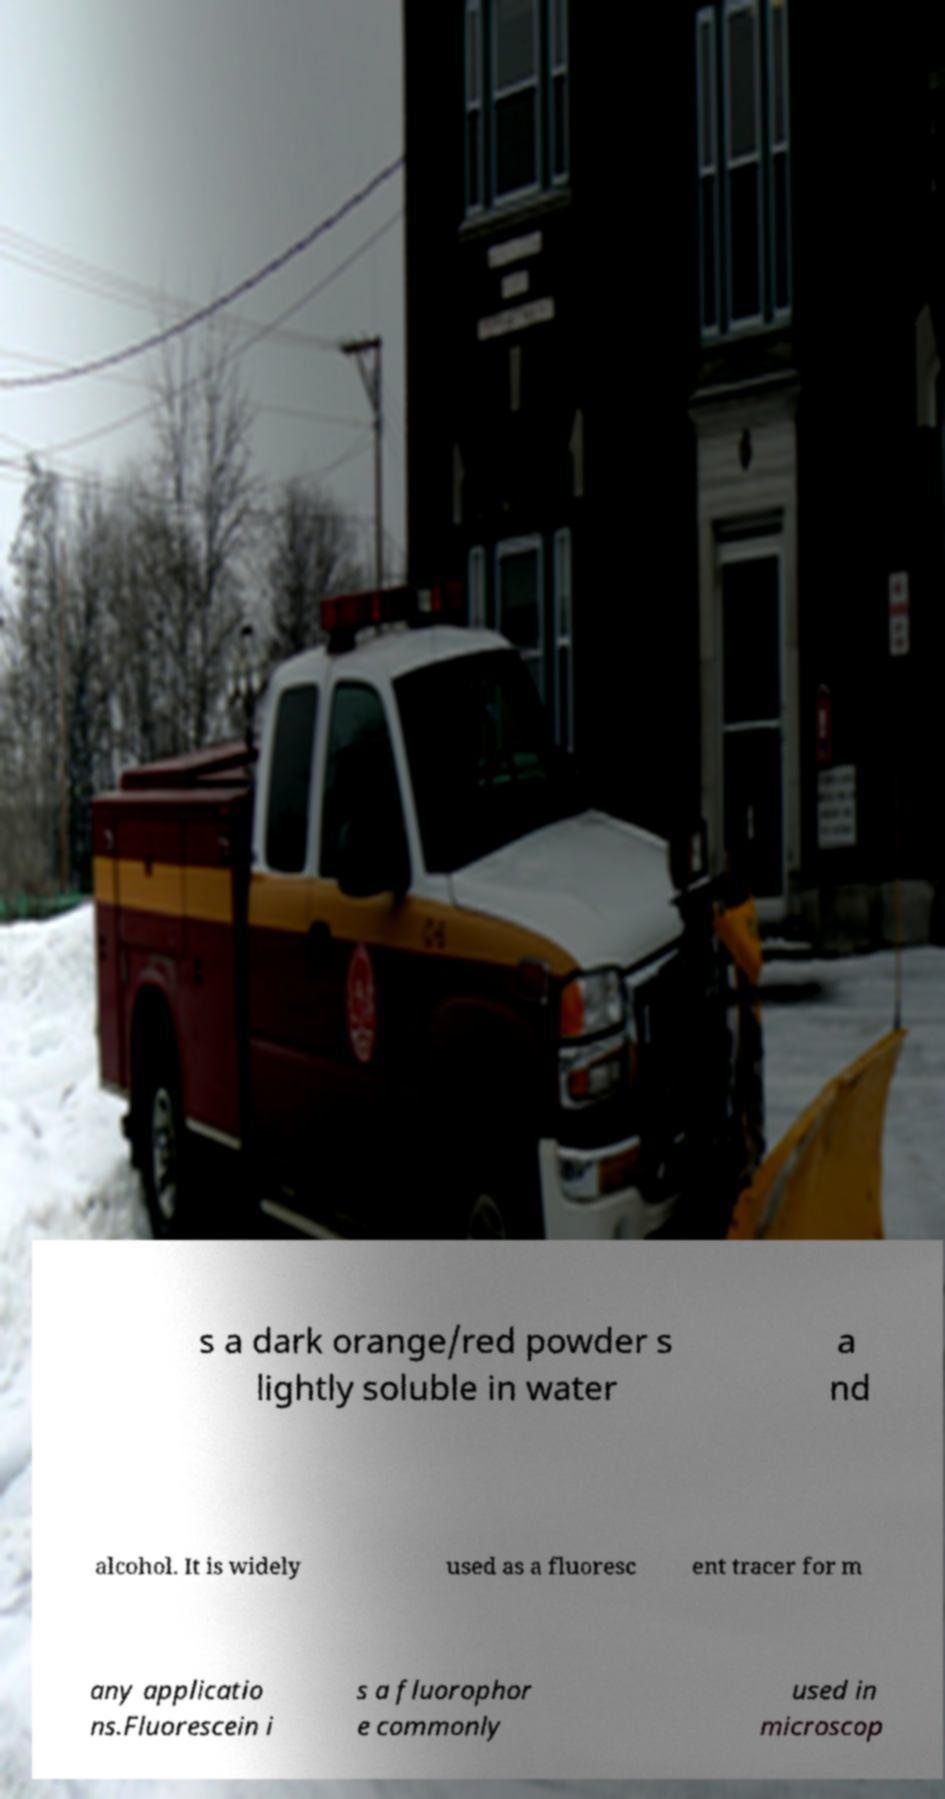Can you read and provide the text displayed in the image?This photo seems to have some interesting text. Can you extract and type it out for me? s a dark orange/red powder s lightly soluble in water a nd alcohol. It is widely used as a fluoresc ent tracer for m any applicatio ns.Fluorescein i s a fluorophor e commonly used in microscop 